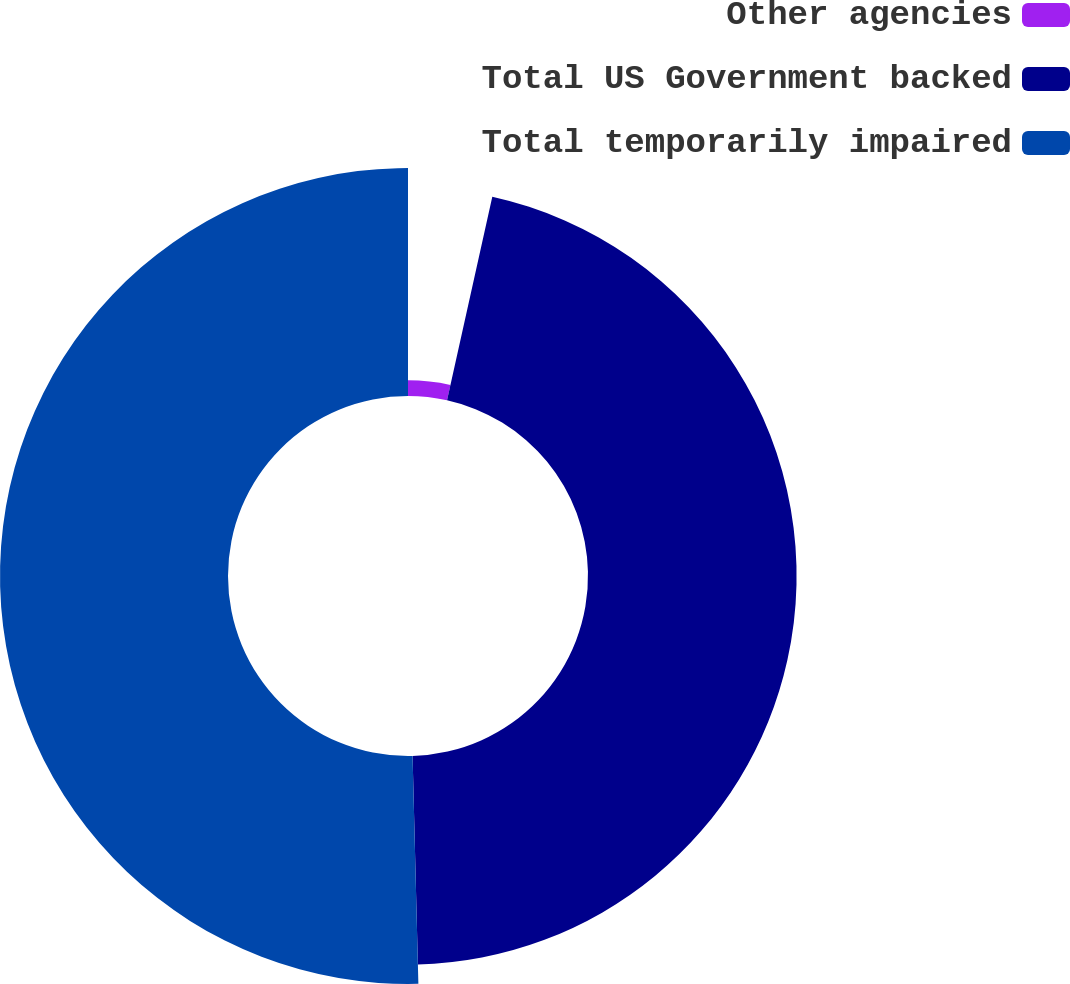Convert chart. <chart><loc_0><loc_0><loc_500><loc_500><pie_chart><fcel>Other agencies<fcel>Total US Government backed<fcel>Total temporarily impaired<nl><fcel>3.48%<fcel>46.11%<fcel>50.4%<nl></chart> 